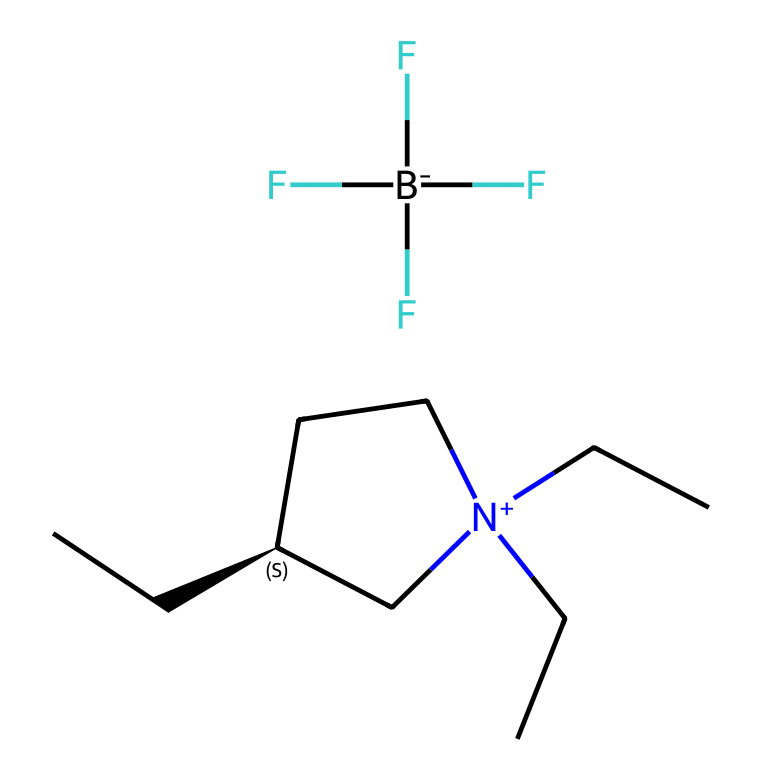How many carbon atoms are in the structure? By analyzing the SMILES representation, we can count each carbon atom explicitly shown in the structure. The '[C@H]' and 'CC' groups indicate carbon atoms. Thus, counting gives a total of 12 carbon atoms.
Answer: 12 What type of ion is represented by [B-](F)(F)(F)F? The '[B-]' notation indicates a negatively charged boron ion, specifically boron tetrafluoride, where boron is bonded to four fluorine atoms.
Answer: boron How many nitrogen atoms are present in the chemical structure? Examining the SMILES representation, the nitrogen atom '[N+]' can be identified. There is one nitrogen atom in this structure.
Answer: 1 What is the charge of the nitrogen atom in this ionic liquid? The '[N+]' notation indicates that the nitrogen atom has a positive charge. Therefore, it is a cation in this ionic liquid.
Answer: positive What kind of functional groups are likely present in this ionic liquid based on its structure? The presence of the '[N+]' indicates a quaternary ammonium group, and the haloalkane indicated by 'F' suggests the presence of halide functional groups. These functional groups are significant in ionic liquids.
Answer: quaternary ammonium and halide Is this ionic liquid likely to be hydrophilic or hydrophobic? The combination of chains from the quaternary ammonium structure generally makes such ionic liquids hydrophobic, as long carbon chains are typically associated with hydrophobic characteristics.
Answer: hydrophobic What is the significance of the fluorine atoms in terms of conductivity? The fluorine atoms contribute to the ionic nature of the compound, which enhances the electrical conductivity essential for conductive coatings. The electronegative fluorine helps stabilize the ionic charge.
Answer: conductivity 